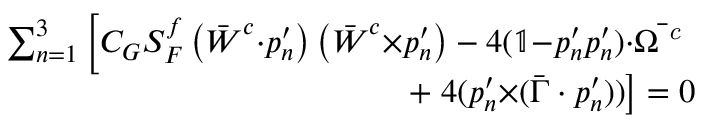Convert formula to latex. <formula><loc_0><loc_0><loc_500><loc_500>\begin{array} { r } { \sum _ { n = 1 } ^ { 3 } \left [ C _ { G } S _ { F } ^ { f } \left ( \bar { W } ^ { c } { \cdot } p _ { n } ^ { \prime } \right ) \left ( \bar { W } ^ { c } { \times } p _ { n } ^ { \prime } \right ) - 4 ( \mathbb { 1 } { - } p _ { n } ^ { \prime } p _ { n } ^ { \prime } ) { \cdot } \bar { \Omega ^ { c } } } \\ { + 4 ( p _ { n } ^ { \prime } { \times } ( \bar { \Gamma } \cdot p _ { n } ^ { \prime } ) ) \right ] = 0 } \end{array}</formula> 